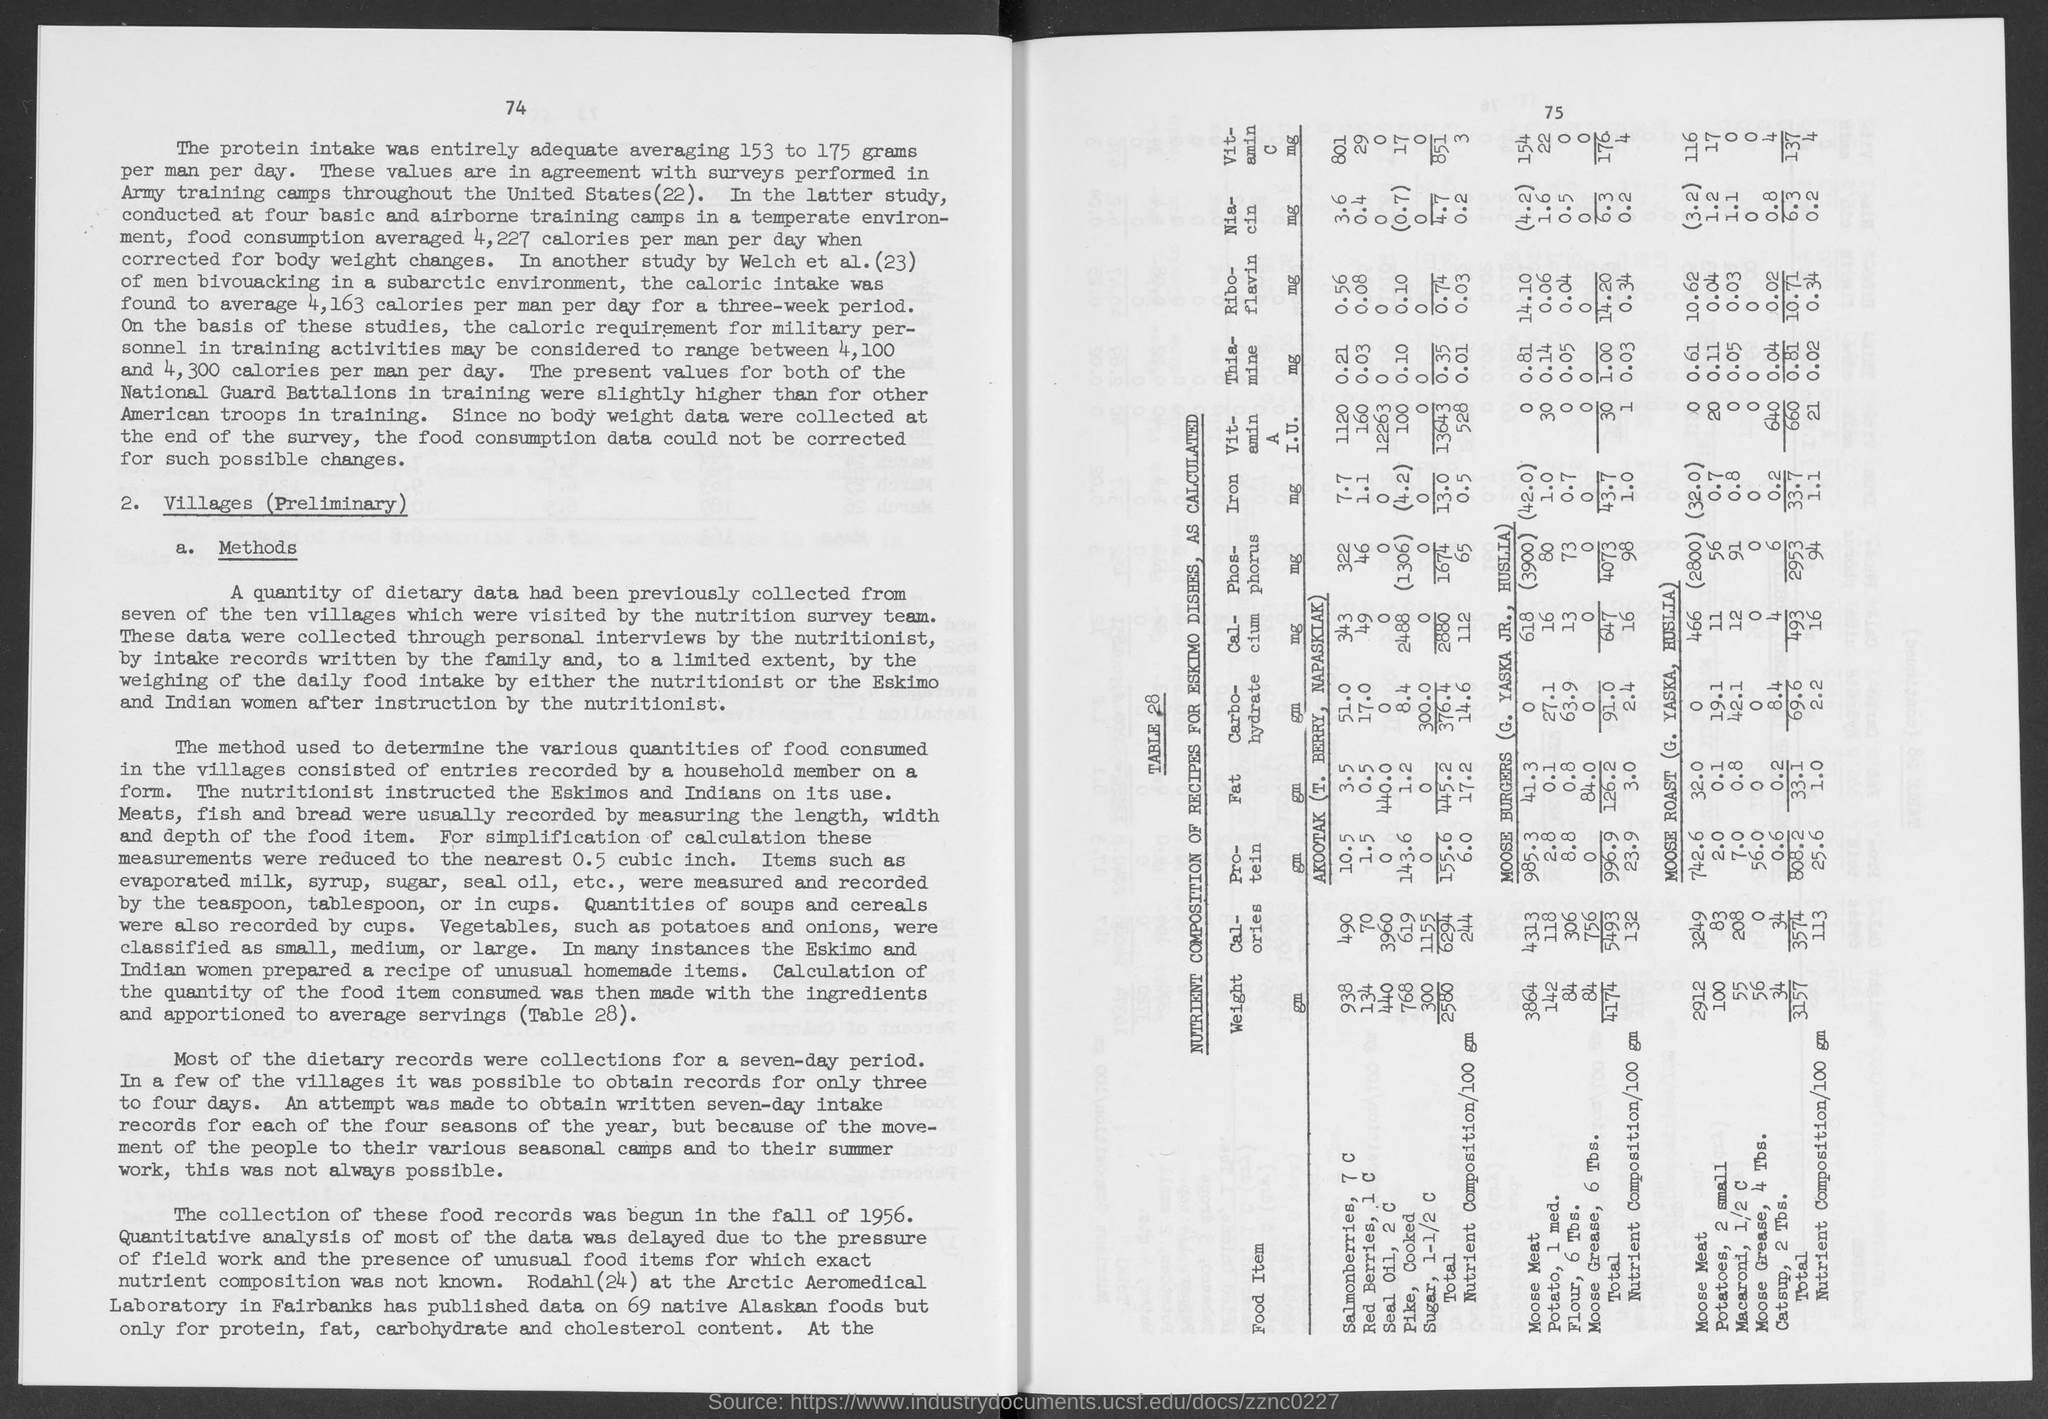Specify some key components in this picture. The number at the top-right corner of the page is 75. 